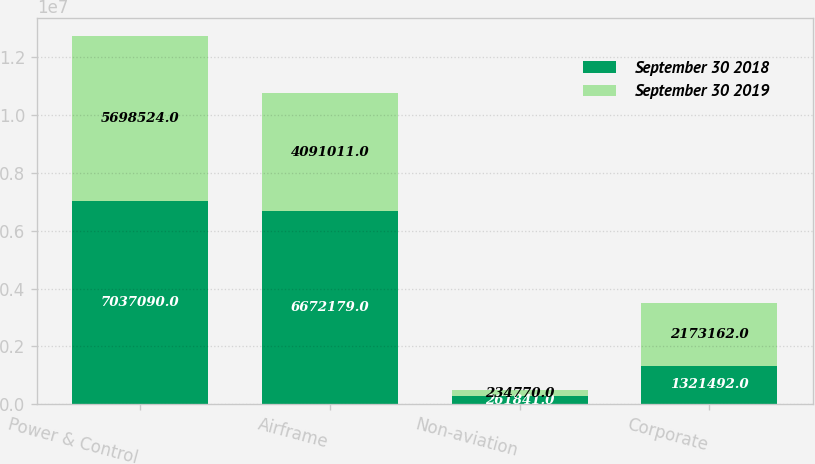Convert chart. <chart><loc_0><loc_0><loc_500><loc_500><stacked_bar_chart><ecel><fcel>Power & Control<fcel>Airframe<fcel>Non-aviation<fcel>Corporate<nl><fcel>September 30 2018<fcel>7.03709e+06<fcel>6.67218e+06<fcel>261841<fcel>1.32149e+06<nl><fcel>September 30 2019<fcel>5.69852e+06<fcel>4.09101e+06<fcel>234770<fcel>2.17316e+06<nl></chart> 